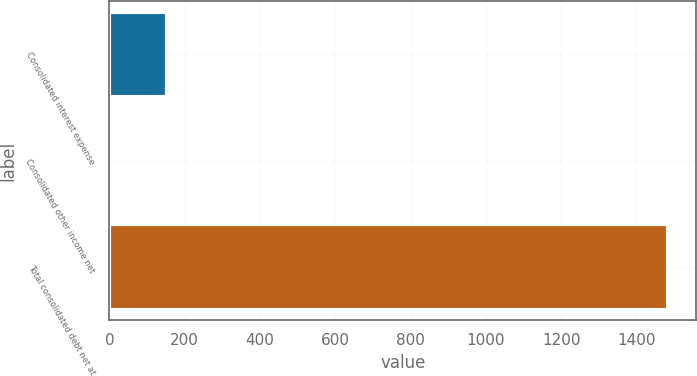<chart> <loc_0><loc_0><loc_500><loc_500><bar_chart><fcel>Consolidated interest expense<fcel>Consolidated other income net<fcel>Total consolidated debt net at<nl><fcel>152.14<fcel>4.1<fcel>1484.5<nl></chart> 